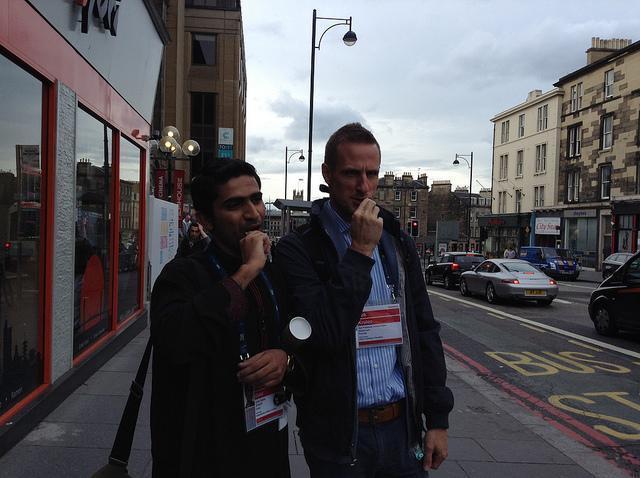How many people are talking on the phone?
Give a very brief answer. 0. How many cameras do the men have?
Give a very brief answer. 0. How many cars are going down the road?
Give a very brief answer. 3. How many people are shown?
Give a very brief answer. 2. How many people are holding onto a bike in this image?
Give a very brief answer. 0. How many people in the shot?
Give a very brief answer. 2. How many cars are there?
Give a very brief answer. 2. How many people are in the picture?
Give a very brief answer. 2. 